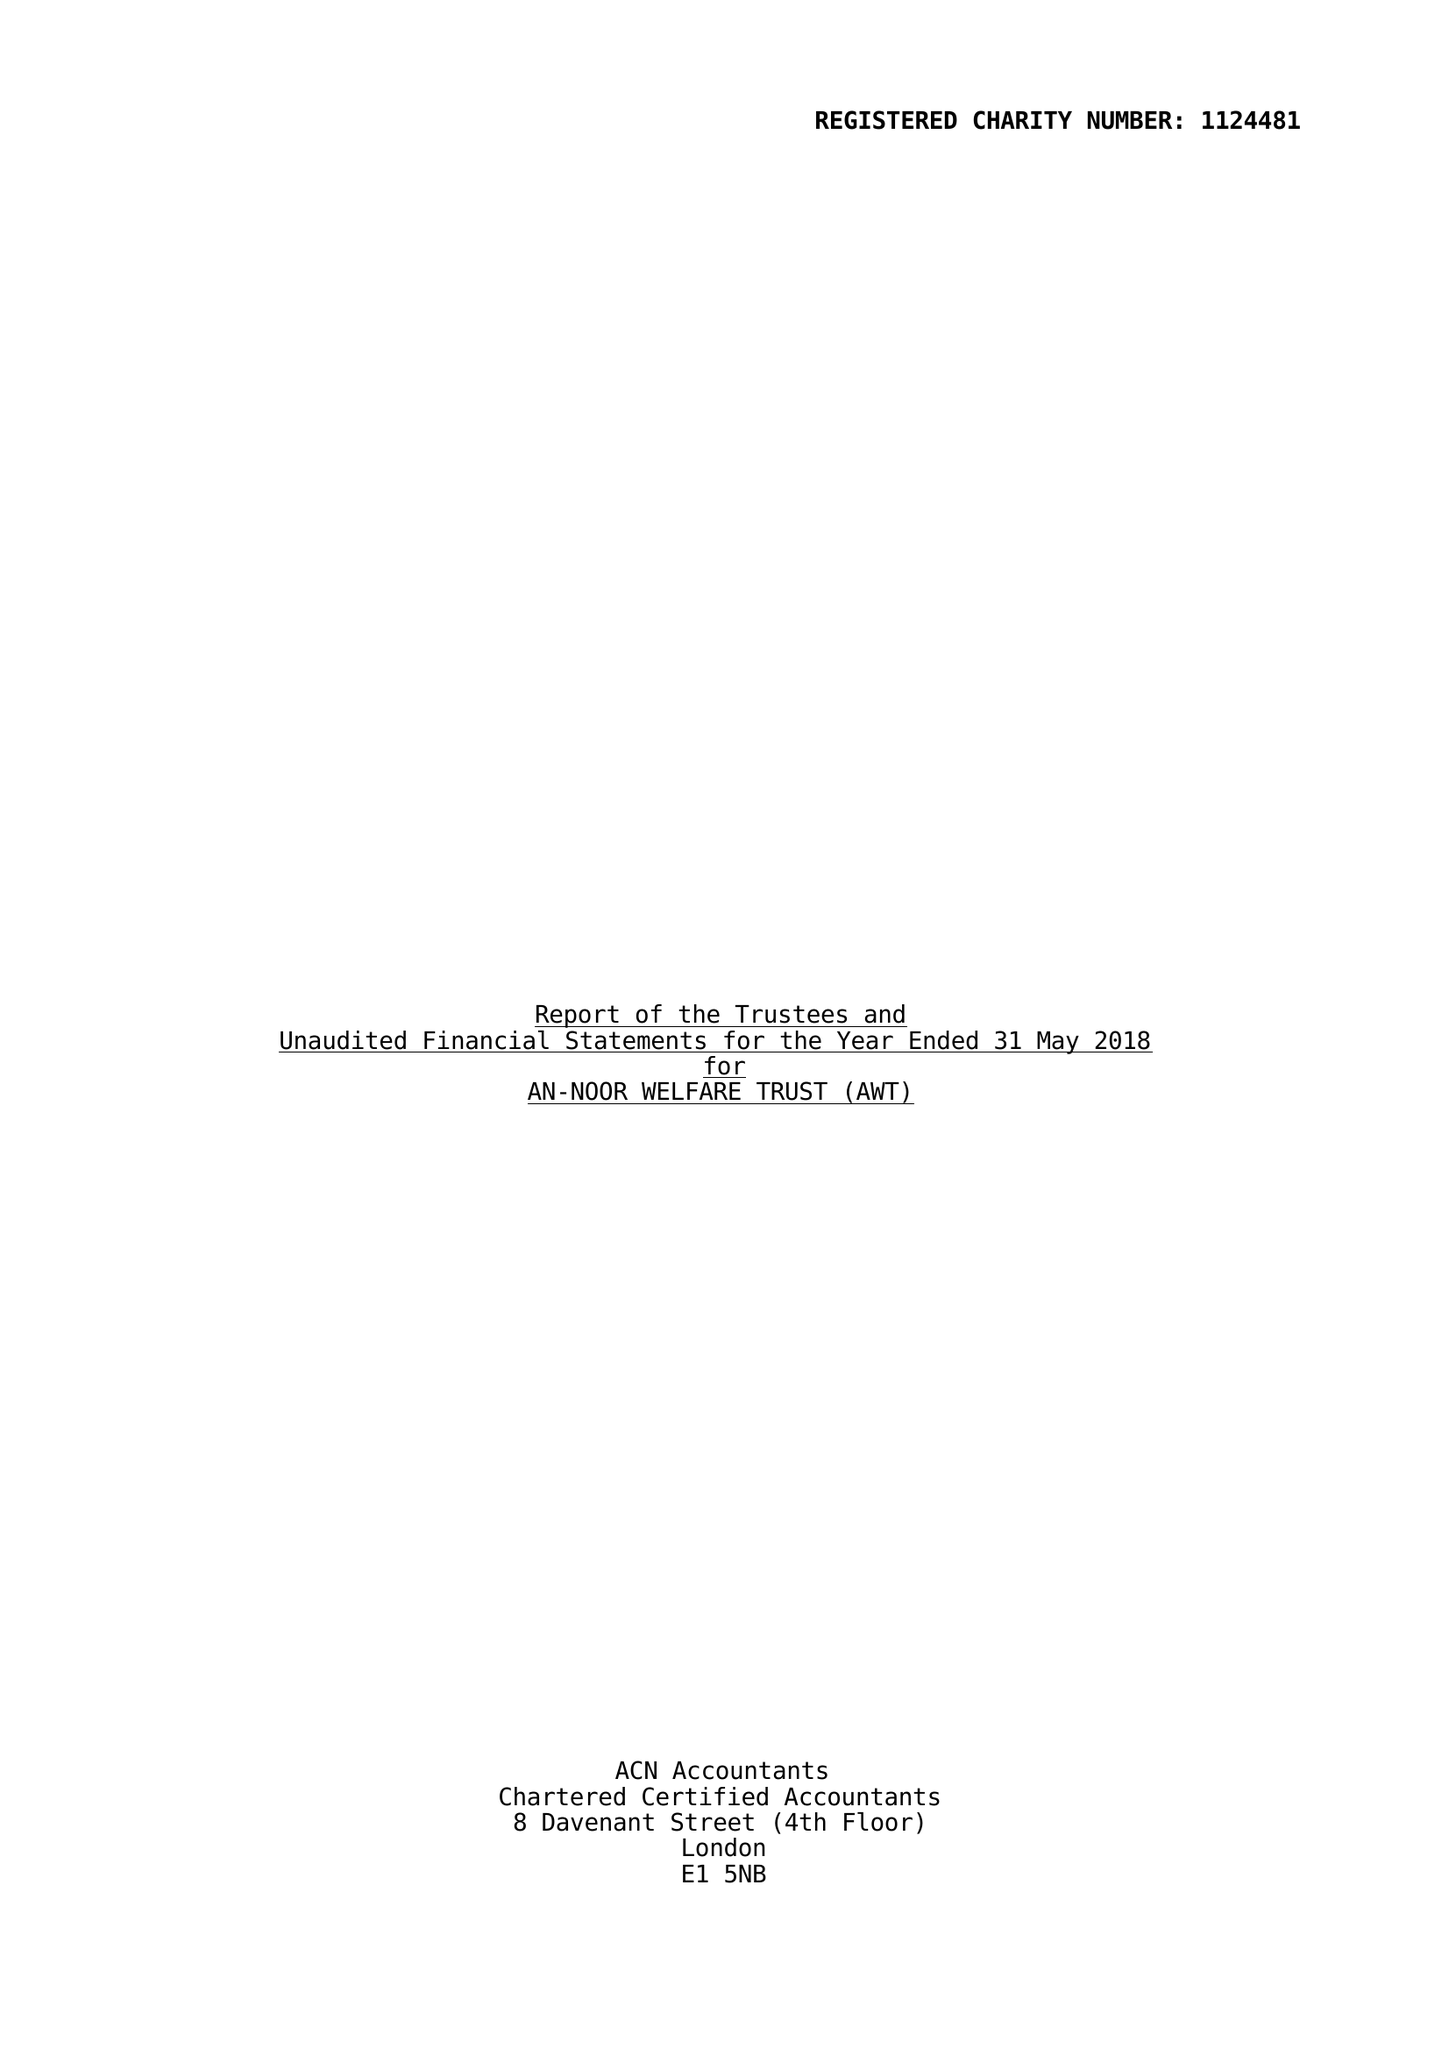What is the value for the address__post_town?
Answer the question using a single word or phrase. LONDON 